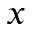<formula> <loc_0><loc_0><loc_500><loc_500>x</formula> 